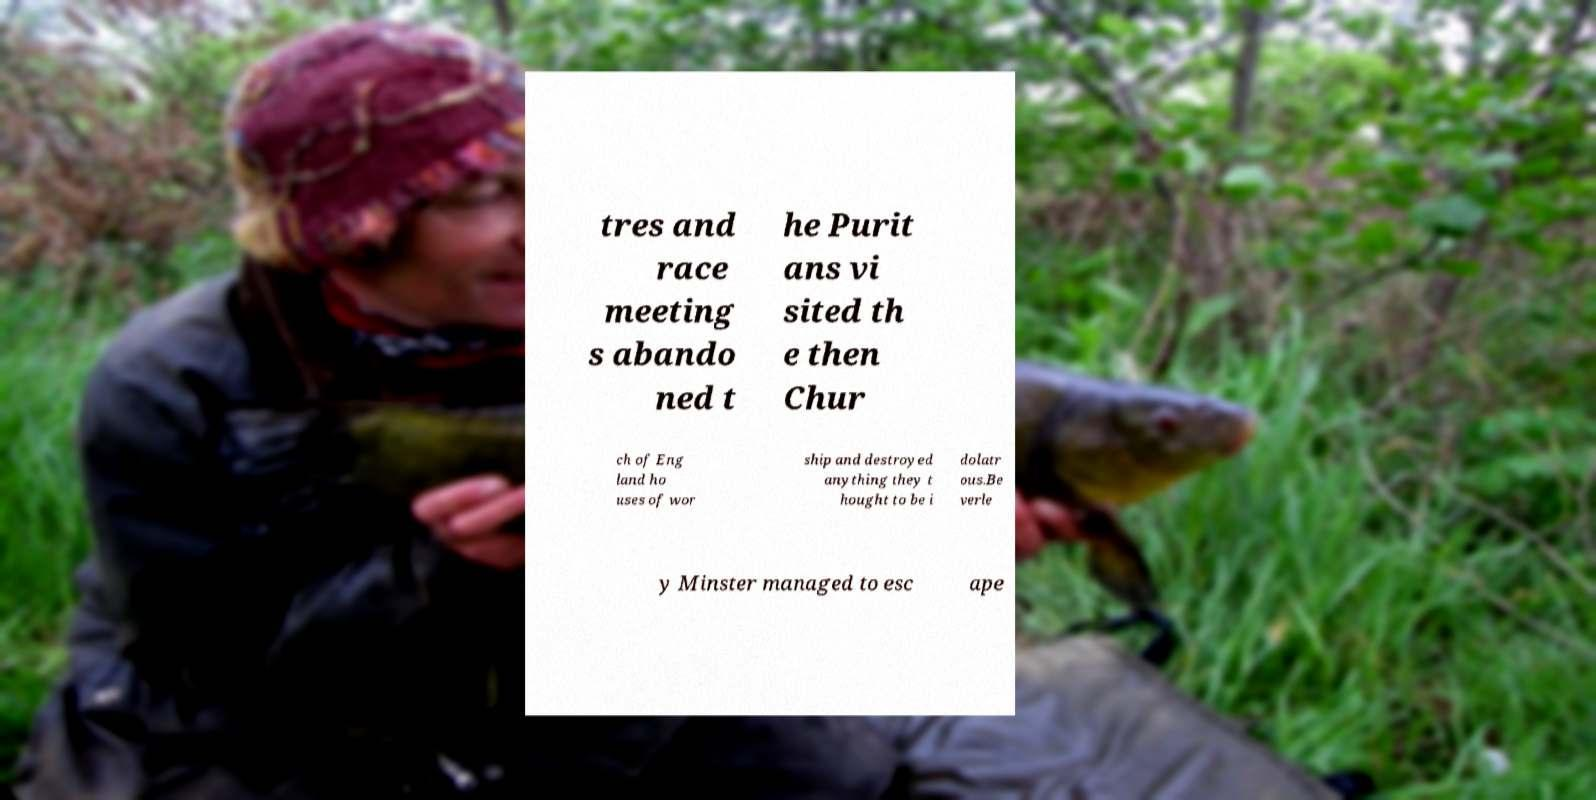Please read and relay the text visible in this image. What does it say? tres and race meeting s abando ned t he Purit ans vi sited th e then Chur ch of Eng land ho uses of wor ship and destroyed anything they t hought to be i dolatr ous.Be verle y Minster managed to esc ape 